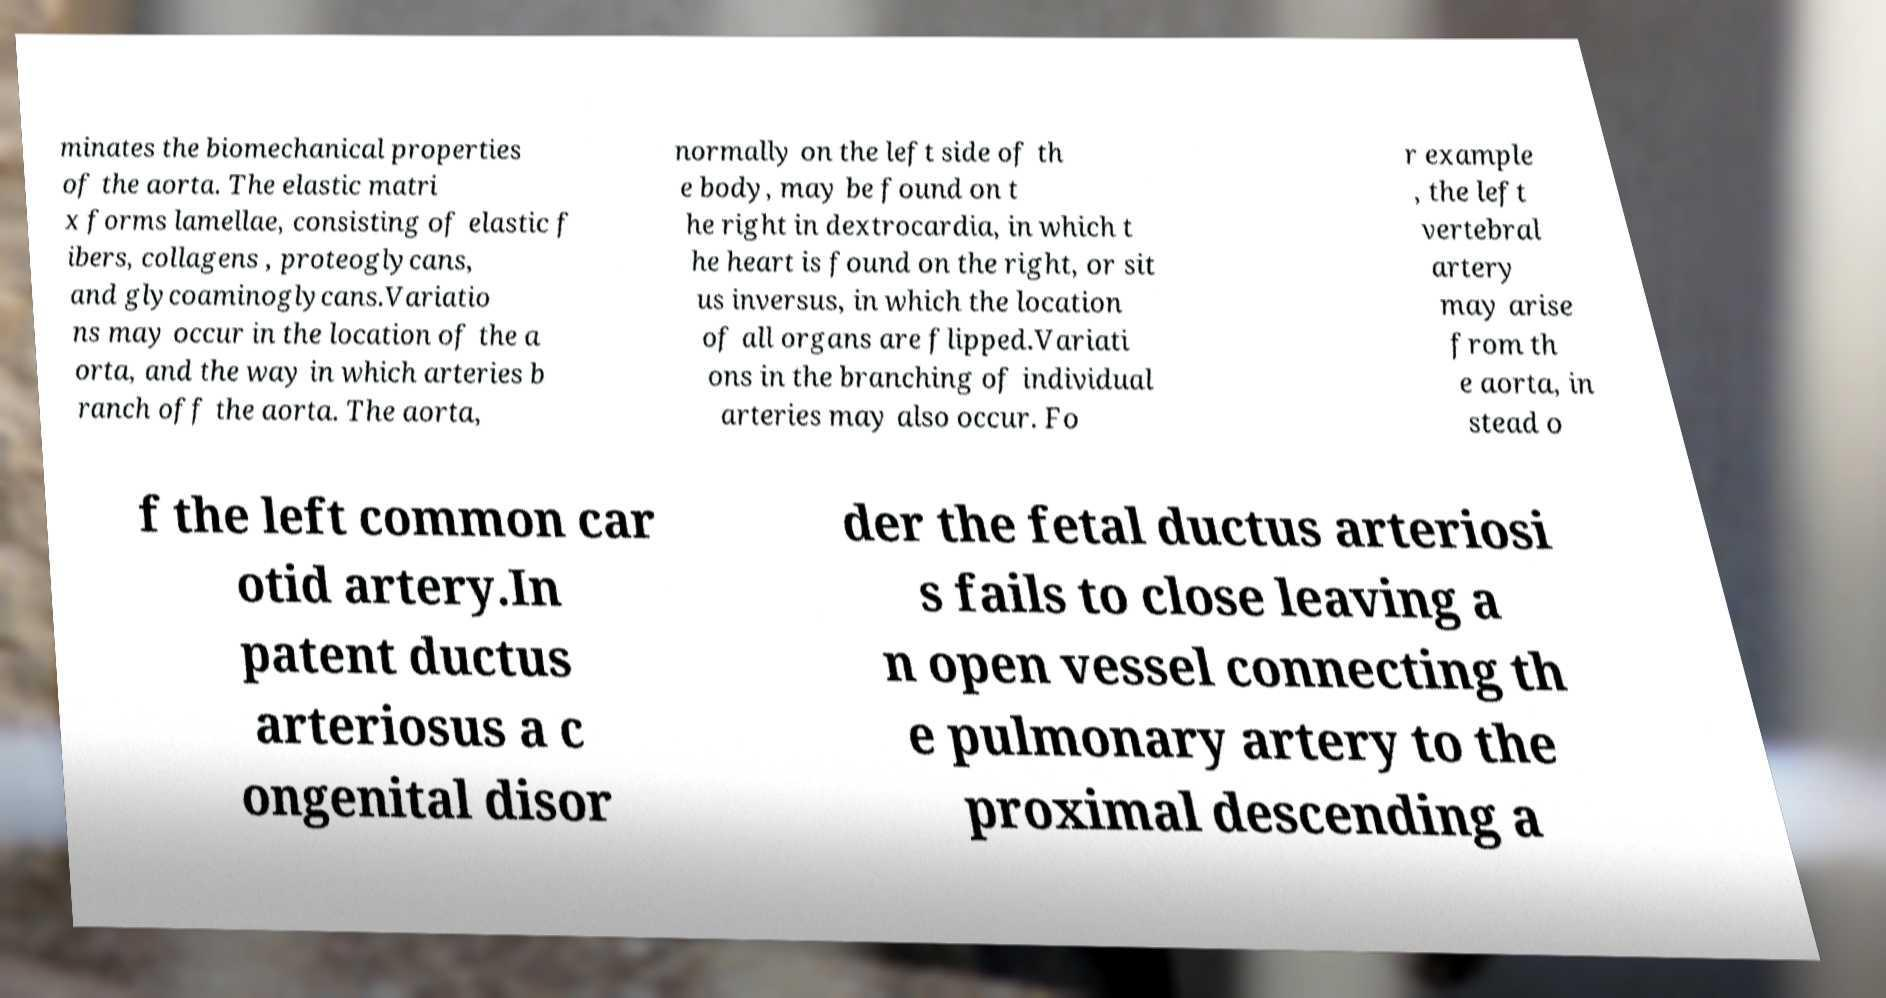Can you accurately transcribe the text from the provided image for me? minates the biomechanical properties of the aorta. The elastic matri x forms lamellae, consisting of elastic f ibers, collagens , proteoglycans, and glycoaminoglycans.Variatio ns may occur in the location of the a orta, and the way in which arteries b ranch off the aorta. The aorta, normally on the left side of th e body, may be found on t he right in dextrocardia, in which t he heart is found on the right, or sit us inversus, in which the location of all organs are flipped.Variati ons in the branching of individual arteries may also occur. Fo r example , the left vertebral artery may arise from th e aorta, in stead o f the left common car otid artery.In patent ductus arteriosus a c ongenital disor der the fetal ductus arteriosi s fails to close leaving a n open vessel connecting th e pulmonary artery to the proximal descending a 